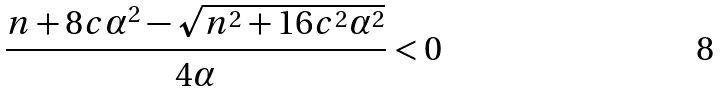<formula> <loc_0><loc_0><loc_500><loc_500>\frac { n + 8 c \alpha ^ { 2 } - \sqrt { n ^ { 2 } + 1 6 c ^ { 2 } \alpha ^ { 2 } } } { 4 \alpha } < 0</formula> 